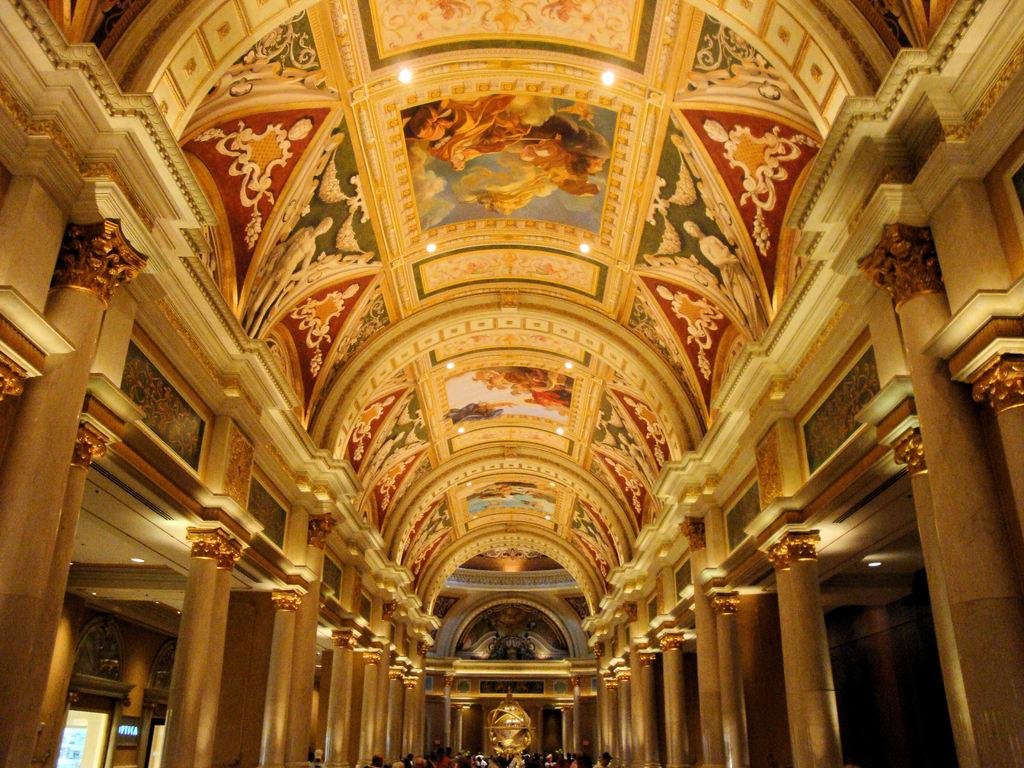What architectural feature can be seen in the image? There are pillars in the image. Who or what is present in the image? There are people in the image. What part of the building is visible in the image? The ceiling is visible in the image. What can be seen on the ceiling? There are lights on the ceiling. What type of spark can be seen coming from the pillars in the image? There is no spark present in the image; the pillars are stationary architectural features. 